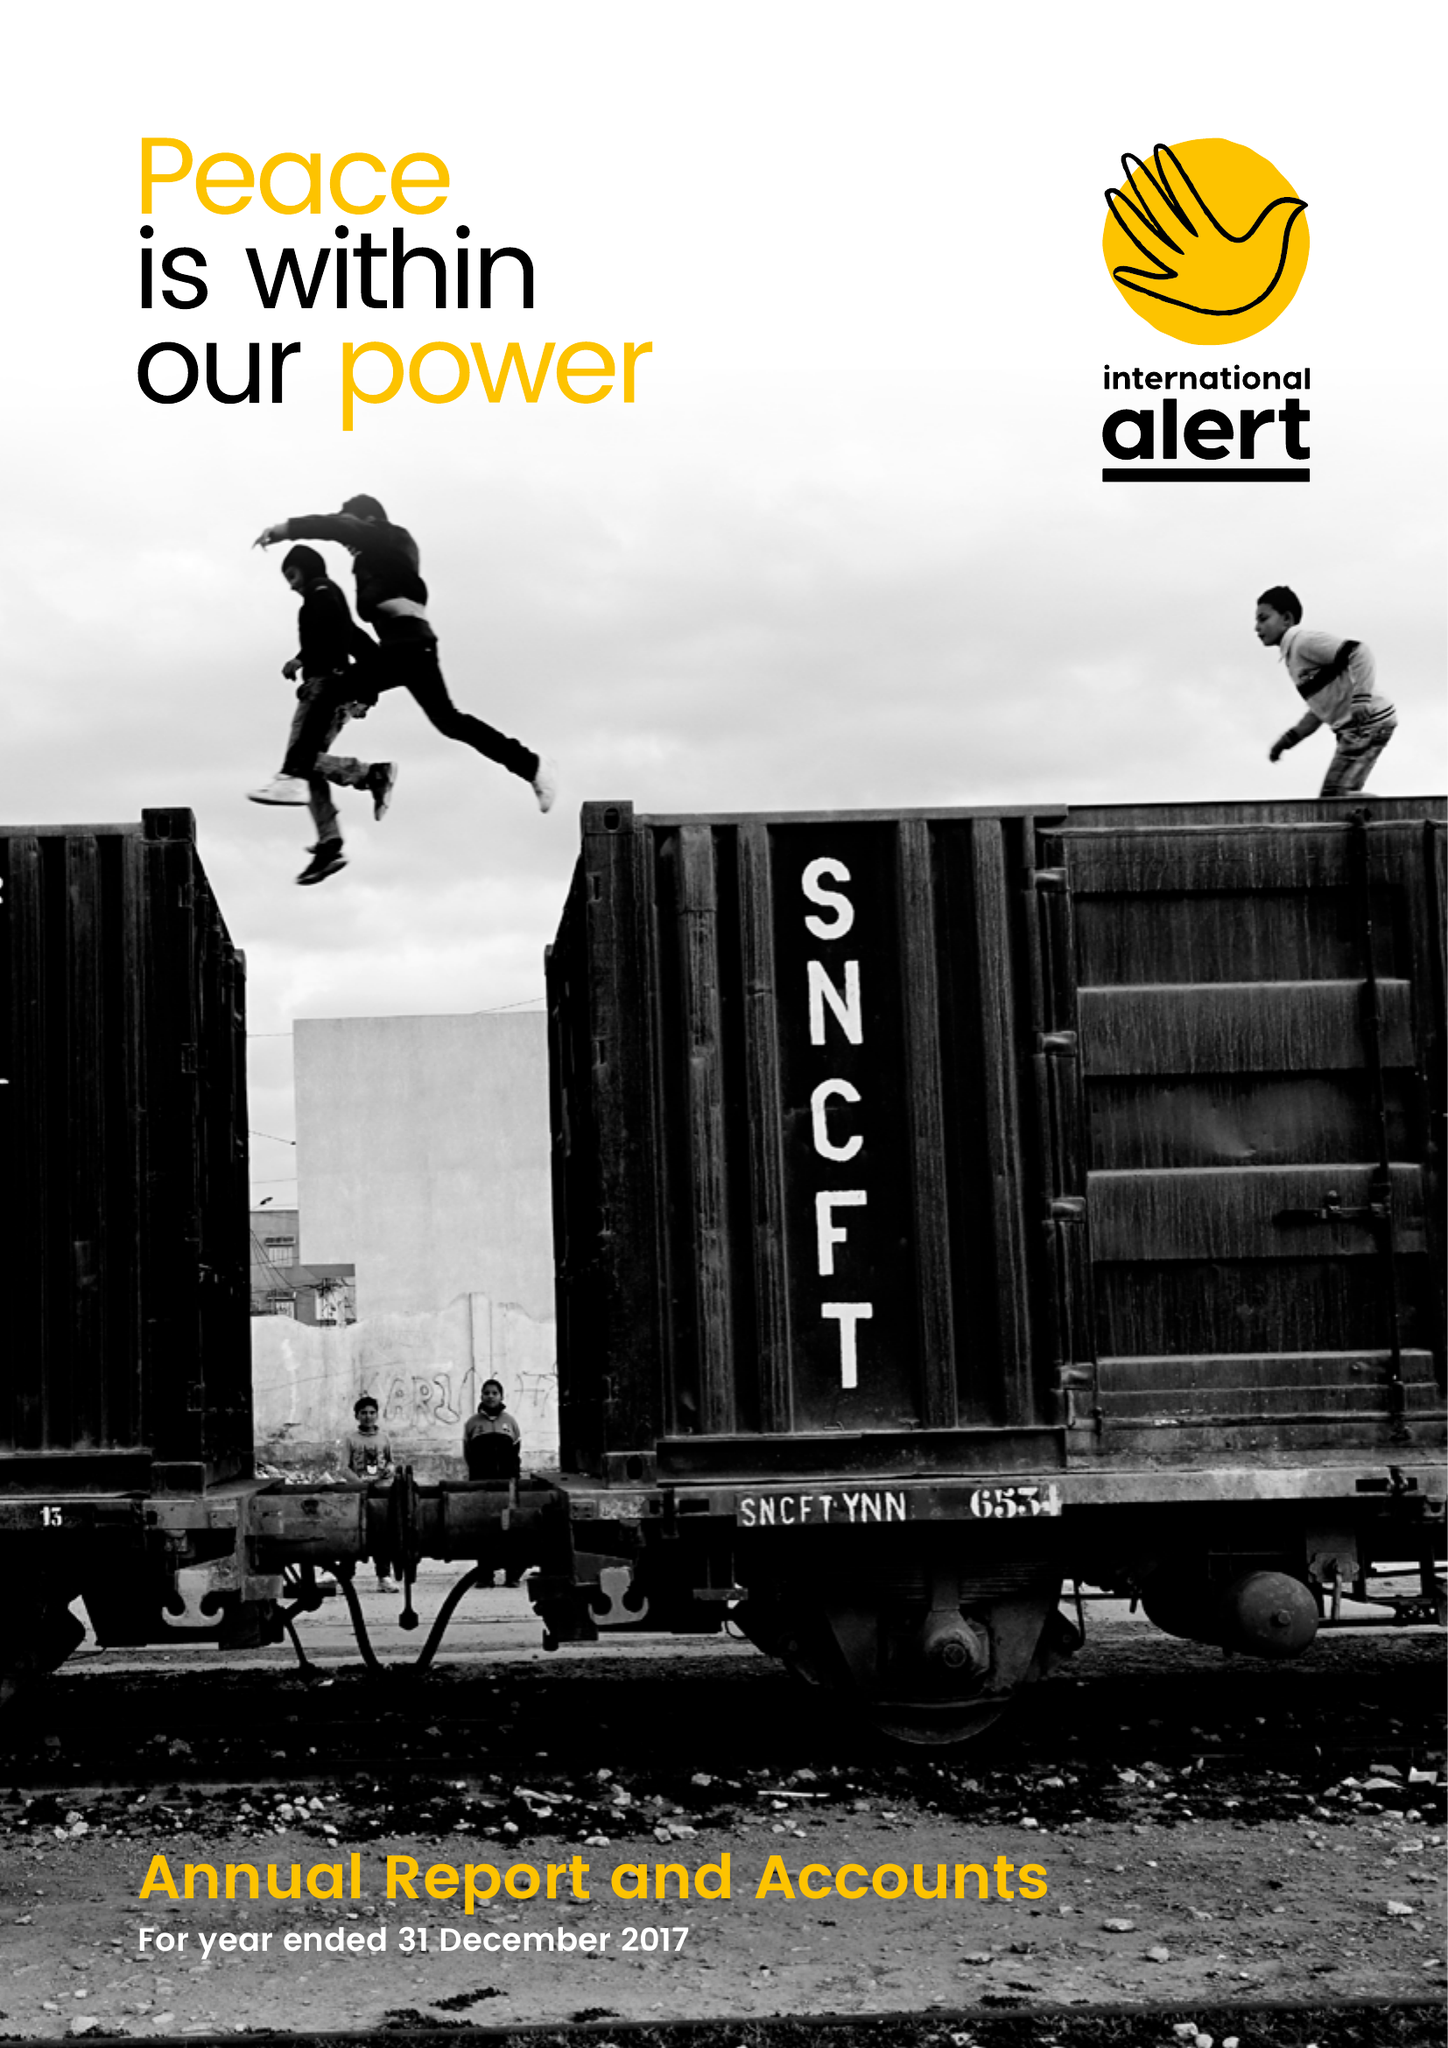What is the value for the address__postcode?
Answer the question using a single word or phrase. SW9 9AP 